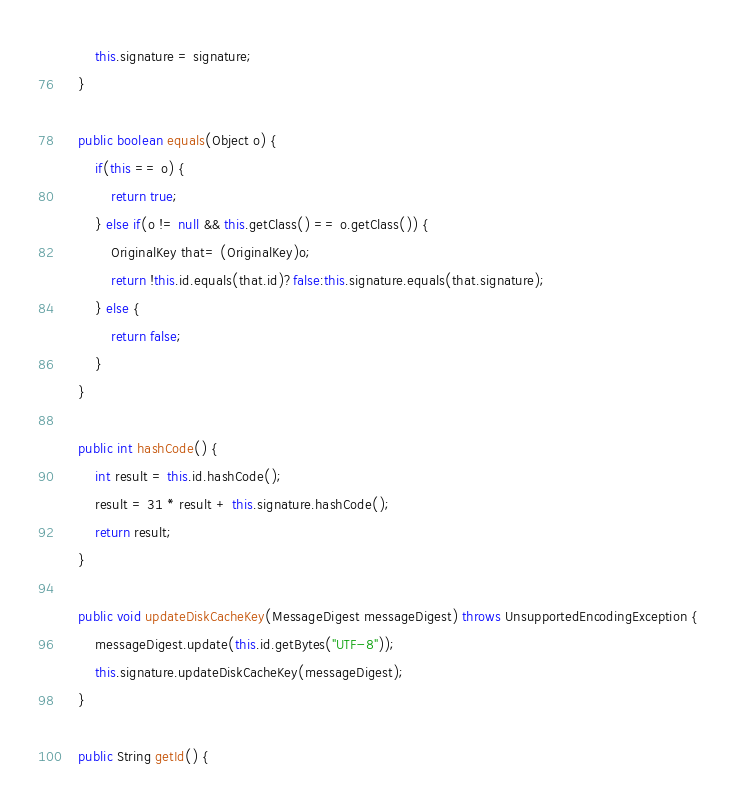Convert code to text. <code><loc_0><loc_0><loc_500><loc_500><_Java_>        this.signature = signature;
    }

    public boolean equals(Object o) {
        if(this == o) {
            return true;
        } else if(o != null && this.getClass() == o.getClass()) {
            OriginalKey that= (OriginalKey)o;
            return !this.id.equals(that.id)?false:this.signature.equals(that.signature);
        } else {
            return false;
        }
    }

    public int hashCode() {
        int result = this.id.hashCode();
        result = 31 * result + this.signature.hashCode();
        return result;
    }

    public void updateDiskCacheKey(MessageDigest messageDigest) throws UnsupportedEncodingException {
        messageDigest.update(this.id.getBytes("UTF-8"));
        this.signature.updateDiskCacheKey(messageDigest);
    }

    public String getId() {</code> 